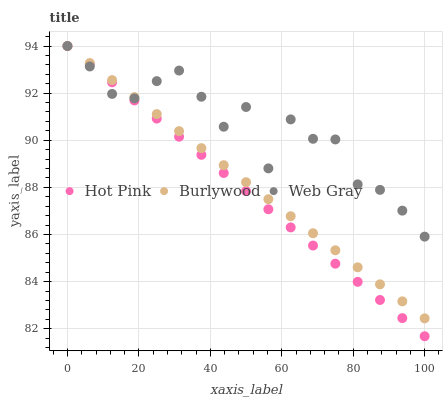Does Hot Pink have the minimum area under the curve?
Answer yes or no. Yes. Does Web Gray have the maximum area under the curve?
Answer yes or no. Yes. Does Web Gray have the minimum area under the curve?
Answer yes or no. No. Does Hot Pink have the maximum area under the curve?
Answer yes or no. No. Is Burlywood the smoothest?
Answer yes or no. Yes. Is Web Gray the roughest?
Answer yes or no. Yes. Is Hot Pink the smoothest?
Answer yes or no. No. Is Hot Pink the roughest?
Answer yes or no. No. Does Hot Pink have the lowest value?
Answer yes or no. Yes. Does Web Gray have the lowest value?
Answer yes or no. No. Does Web Gray have the highest value?
Answer yes or no. Yes. Does Web Gray intersect Hot Pink?
Answer yes or no. Yes. Is Web Gray less than Hot Pink?
Answer yes or no. No. Is Web Gray greater than Hot Pink?
Answer yes or no. No. 